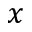Convert formula to latex. <formula><loc_0><loc_0><loc_500><loc_500>x</formula> 